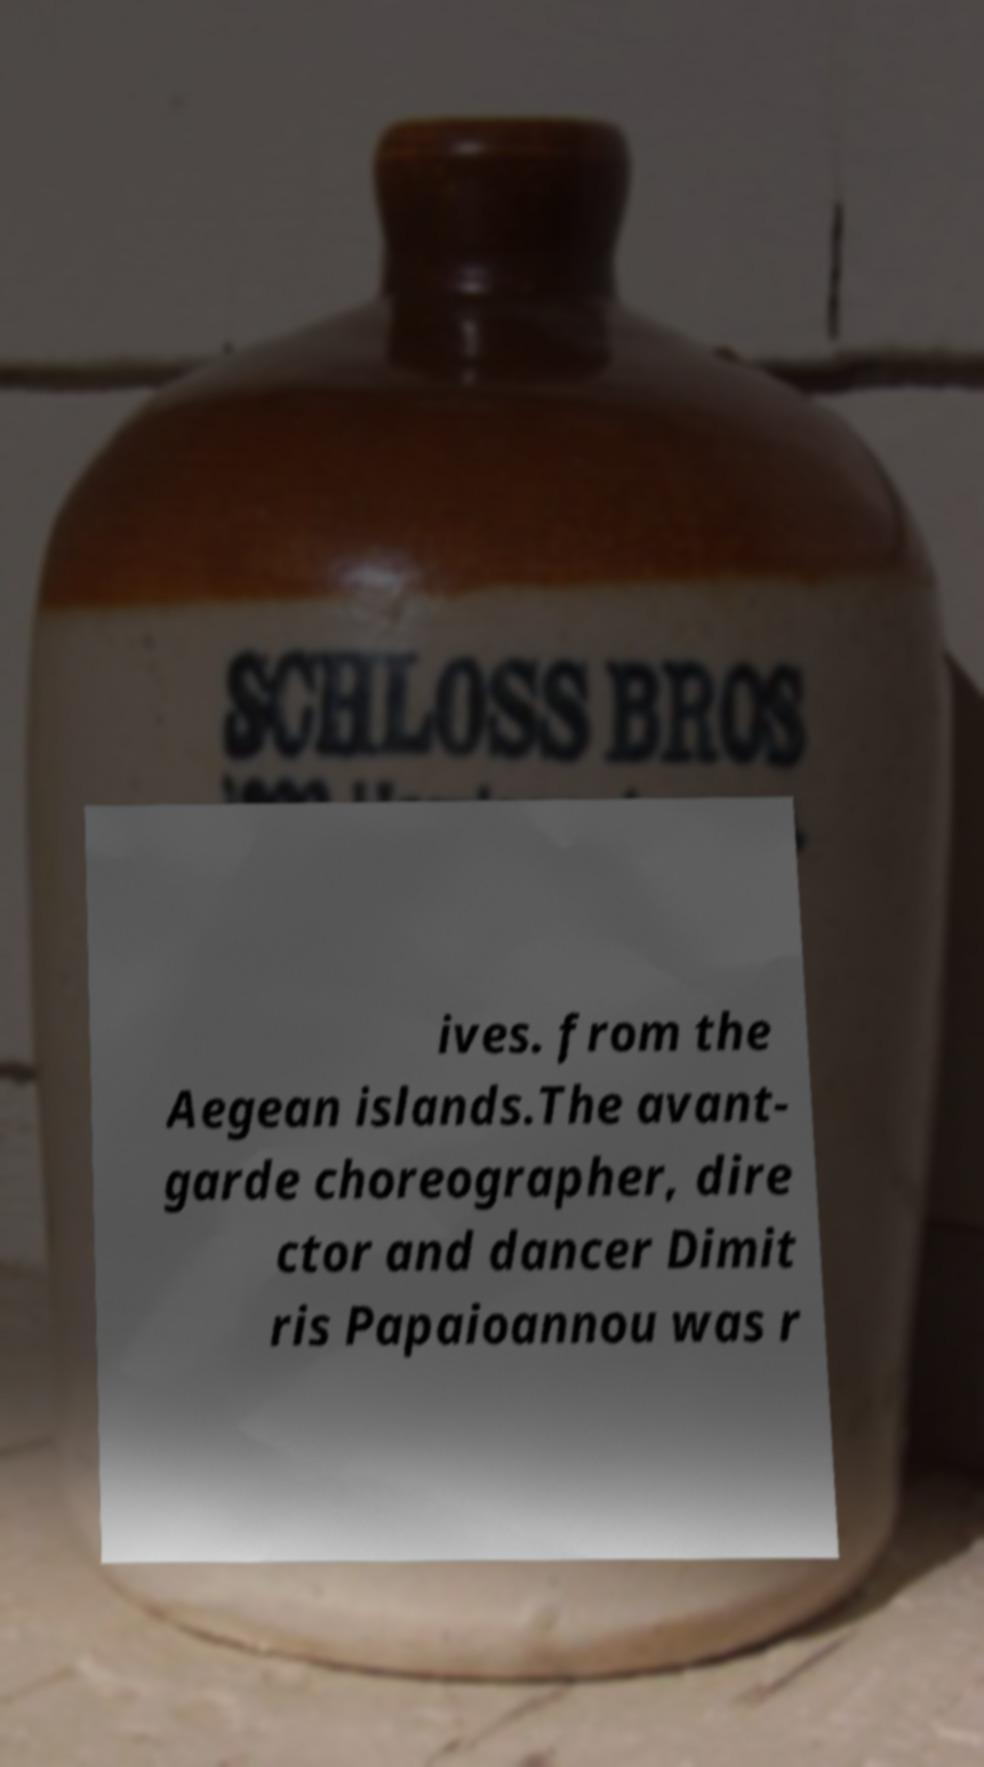Can you read and provide the text displayed in the image?This photo seems to have some interesting text. Can you extract and type it out for me? ives. from the Aegean islands.The avant- garde choreographer, dire ctor and dancer Dimit ris Papaioannou was r 